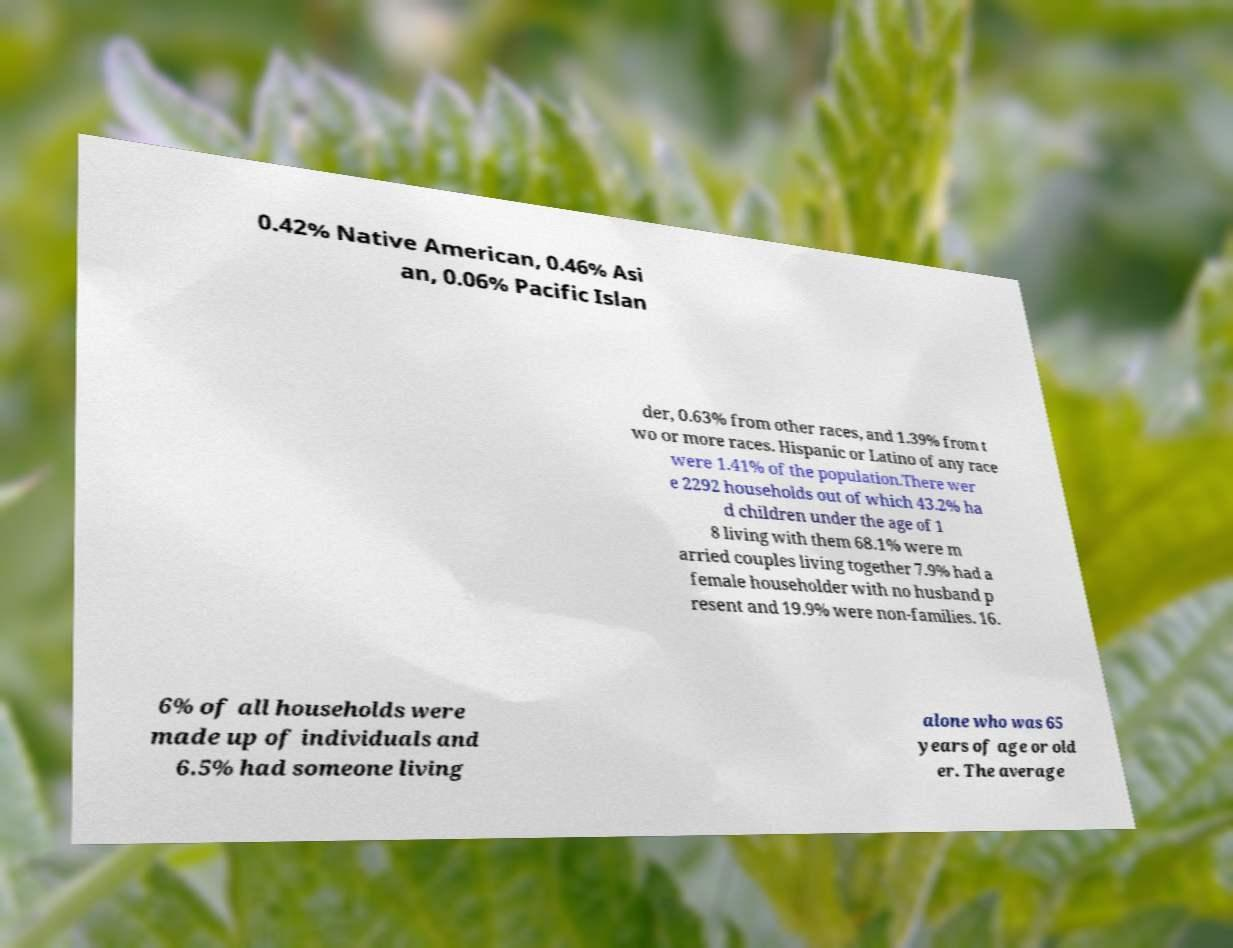Could you assist in decoding the text presented in this image and type it out clearly? 0.42% Native American, 0.46% Asi an, 0.06% Pacific Islan der, 0.63% from other races, and 1.39% from t wo or more races. Hispanic or Latino of any race were 1.41% of the population.There wer e 2292 households out of which 43.2% ha d children under the age of 1 8 living with them 68.1% were m arried couples living together 7.9% had a female householder with no husband p resent and 19.9% were non-families. 16. 6% of all households were made up of individuals and 6.5% had someone living alone who was 65 years of age or old er. The average 